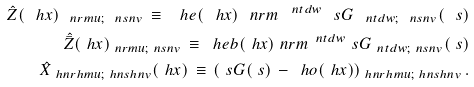<formula> <loc_0><loc_0><loc_500><loc_500>\hat { Z } ( \ h x ) _ { \ n r m u ; \ n s n v } \, \equiv \, \ h e ( \ h x ) _ { \ } n r m ^ { \, \ n t d w } \ s G _ { \ n t d w ; \ n s n v } ( \ s ) \\ \hat { \bar { Z } } ( \ h x ) _ { \ n r m u ; \ n s n v } \, \equiv \, \ h e b ( \ h x ) _ { \ } n r m ^ { \, \ n t d w } \ s G _ { \ n t d w ; \ n s n v } ( \ s ) \\ \hat { X } _ { \ h n r h m u ; \ h n s h n v } ( \ h x ) \, \equiv \, ( \ s G ( \ s ) \, - \, \ h o ( \ h x ) ) _ { \ h n r h m u ; \ h n s h n v } \, .</formula> 